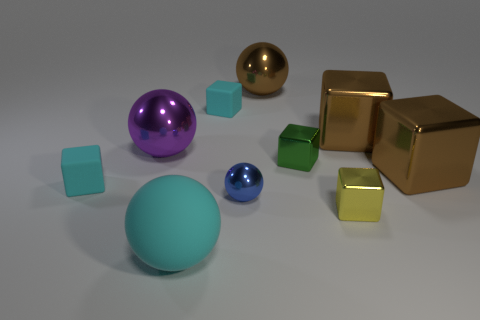The big purple thing that is the same material as the tiny blue sphere is what shape?
Give a very brief answer. Sphere. Is there any other thing that is the same shape as the green metal thing?
Provide a short and direct response. Yes. Is the material of the tiny thing that is to the left of the large purple thing the same as the green block?
Offer a very short reply. No. There is a big ball in front of the tiny yellow metal cube; what is its material?
Make the answer very short. Rubber. There is a brown metal thing in front of the large metal cube that is behind the small green object; what size is it?
Offer a very short reply. Large. What number of shiny blocks are the same size as the yellow shiny object?
Your answer should be compact. 1. There is a big sphere right of the tiny blue metal ball; is it the same color as the large thing that is in front of the yellow shiny thing?
Your response must be concise. No. There is a cyan rubber ball; are there any cyan rubber balls behind it?
Keep it short and to the point. No. There is a shiny sphere that is both right of the big cyan sphere and behind the tiny blue ball; what is its color?
Your answer should be compact. Brown. Are there any tiny shiny cylinders of the same color as the small metallic ball?
Give a very brief answer. No. 